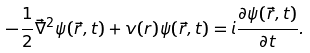Convert formula to latex. <formula><loc_0><loc_0><loc_500><loc_500>- \frac { 1 } { 2 } \vec { \nabla } ^ { 2 } \psi ( \vec { r } , t ) + v ( r ) \psi ( \vec { r } , t ) = i \frac { \partial \psi ( \vec { r } , t ) } { \partial t } .</formula> 